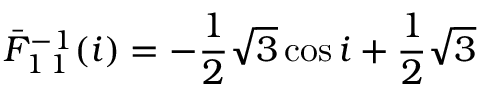Convert formula to latex. <formula><loc_0><loc_0><loc_500><loc_500>\bar { F } _ { 1 \, 1 } ^ { - 1 } ( i ) = - \frac { 1 } { 2 } \sqrt { 3 } \cos i + \frac { 1 } { 2 } \sqrt { 3 }</formula> 